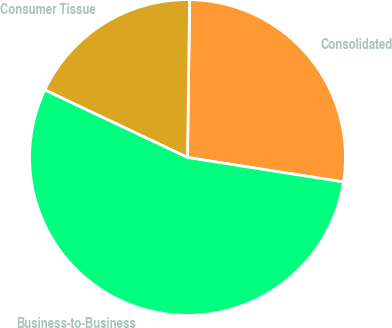Convert chart. <chart><loc_0><loc_0><loc_500><loc_500><pie_chart><fcel>Consolidated<fcel>Consumer Tissue<fcel>Business-to-Business<nl><fcel>27.27%<fcel>18.18%<fcel>54.55%<nl></chart> 